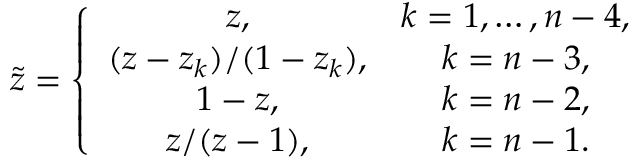Convert formula to latex. <formula><loc_0><loc_0><loc_500><loc_500>\tilde { z } = \left \{ \begin{array} { c c } { z , } & { k = 1 , \dots , n - 4 , } \\ { { ( z - z _ { k } ) / ( 1 - z _ { k } ) , } } & { k = n - 3 , } \\ { 1 - z , } & { k = n - 2 , } \\ { z / ( z - 1 ) , } & { k = n - 1 . } \end{array}</formula> 